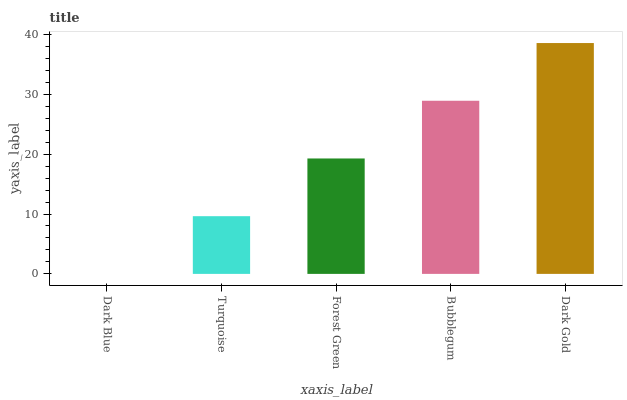Is Dark Blue the minimum?
Answer yes or no. Yes. Is Dark Gold the maximum?
Answer yes or no. Yes. Is Turquoise the minimum?
Answer yes or no. No. Is Turquoise the maximum?
Answer yes or no. No. Is Turquoise greater than Dark Blue?
Answer yes or no. Yes. Is Dark Blue less than Turquoise?
Answer yes or no. Yes. Is Dark Blue greater than Turquoise?
Answer yes or no. No. Is Turquoise less than Dark Blue?
Answer yes or no. No. Is Forest Green the high median?
Answer yes or no. Yes. Is Forest Green the low median?
Answer yes or no. Yes. Is Bubblegum the high median?
Answer yes or no. No. Is Turquoise the low median?
Answer yes or no. No. 